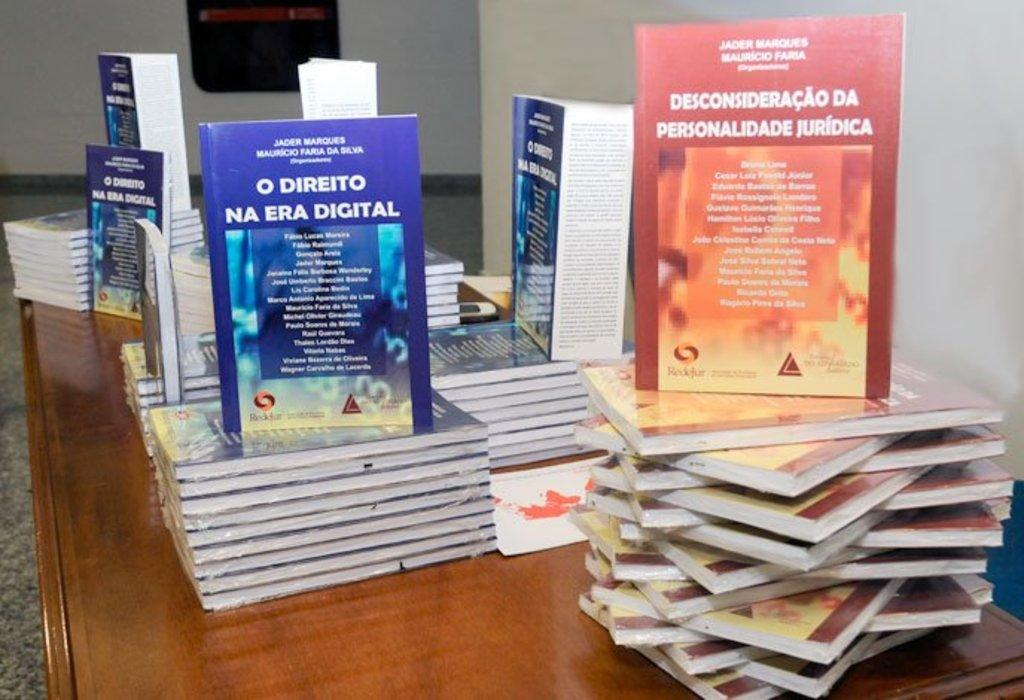<image>
Render a clear and concise summary of the photo. Stacks of books on a wooden table, one featuring the title O Direito Na Era Digital. 